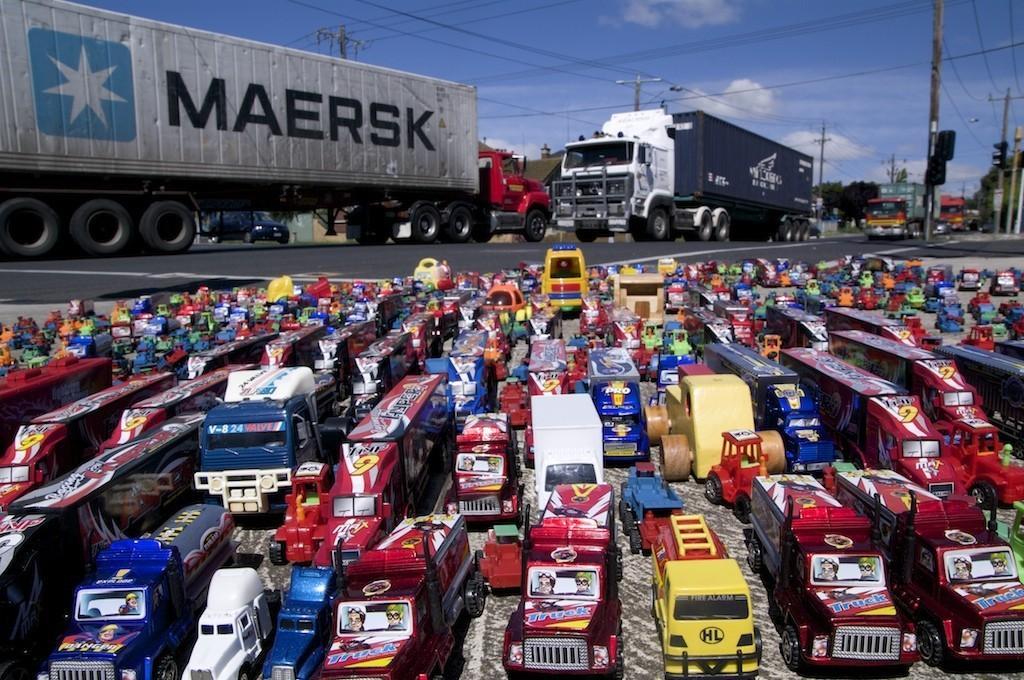How would you summarize this image in a sentence or two? In this image there are vehicles on the road. At the bottom there are toys. In the background there are poles, wires and sky. 